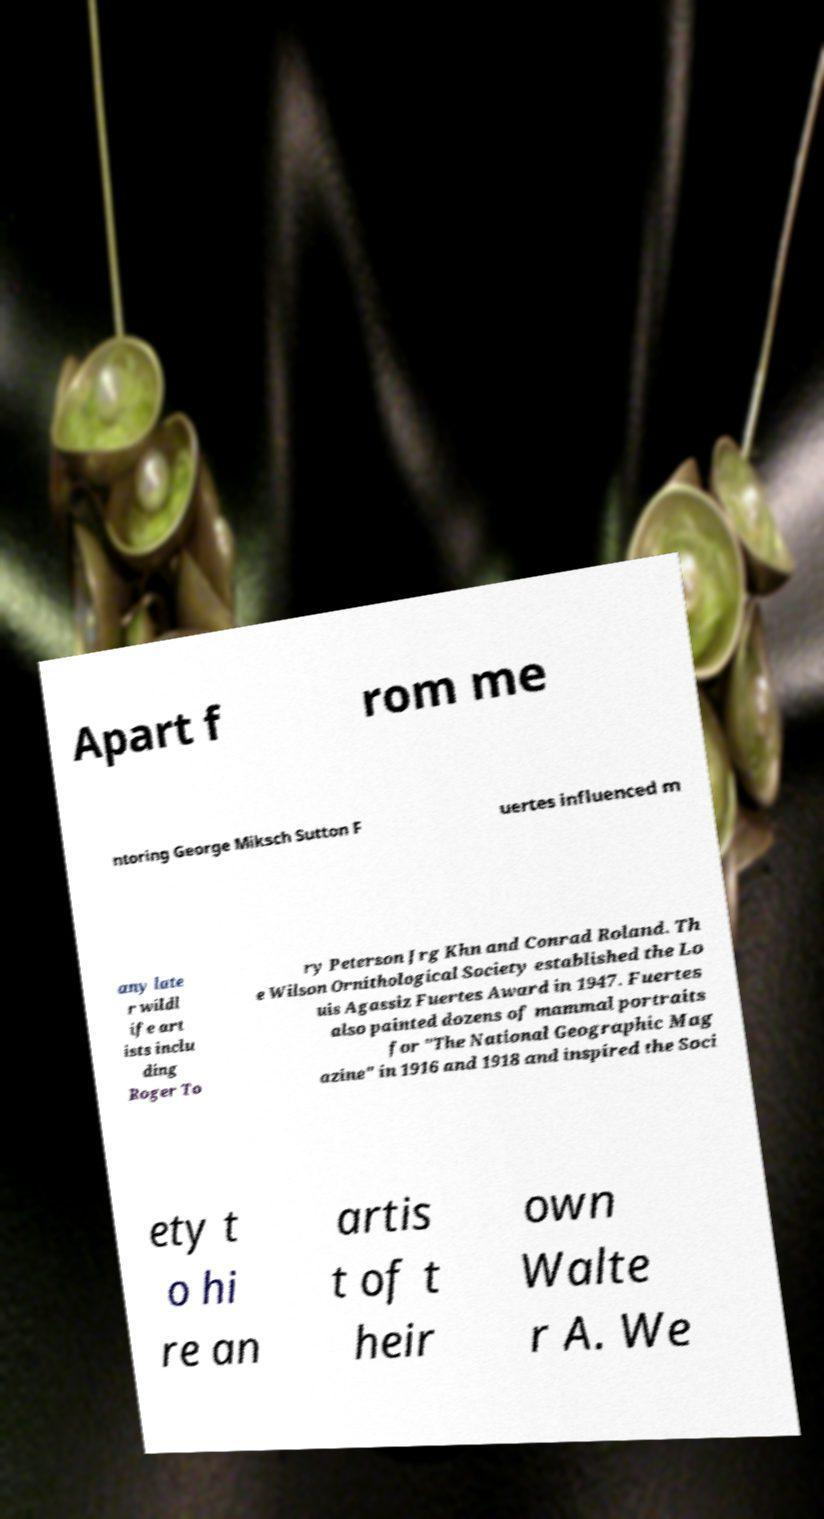Please read and relay the text visible in this image. What does it say? Apart f rom me ntoring George Miksch Sutton F uertes influenced m any late r wildl ife art ists inclu ding Roger To ry Peterson Jrg Khn and Conrad Roland. Th e Wilson Ornithological Society established the Lo uis Agassiz Fuertes Award in 1947. Fuertes also painted dozens of mammal portraits for "The National Geographic Mag azine" in 1916 and 1918 and inspired the Soci ety t o hi re an artis t of t heir own Walte r A. We 